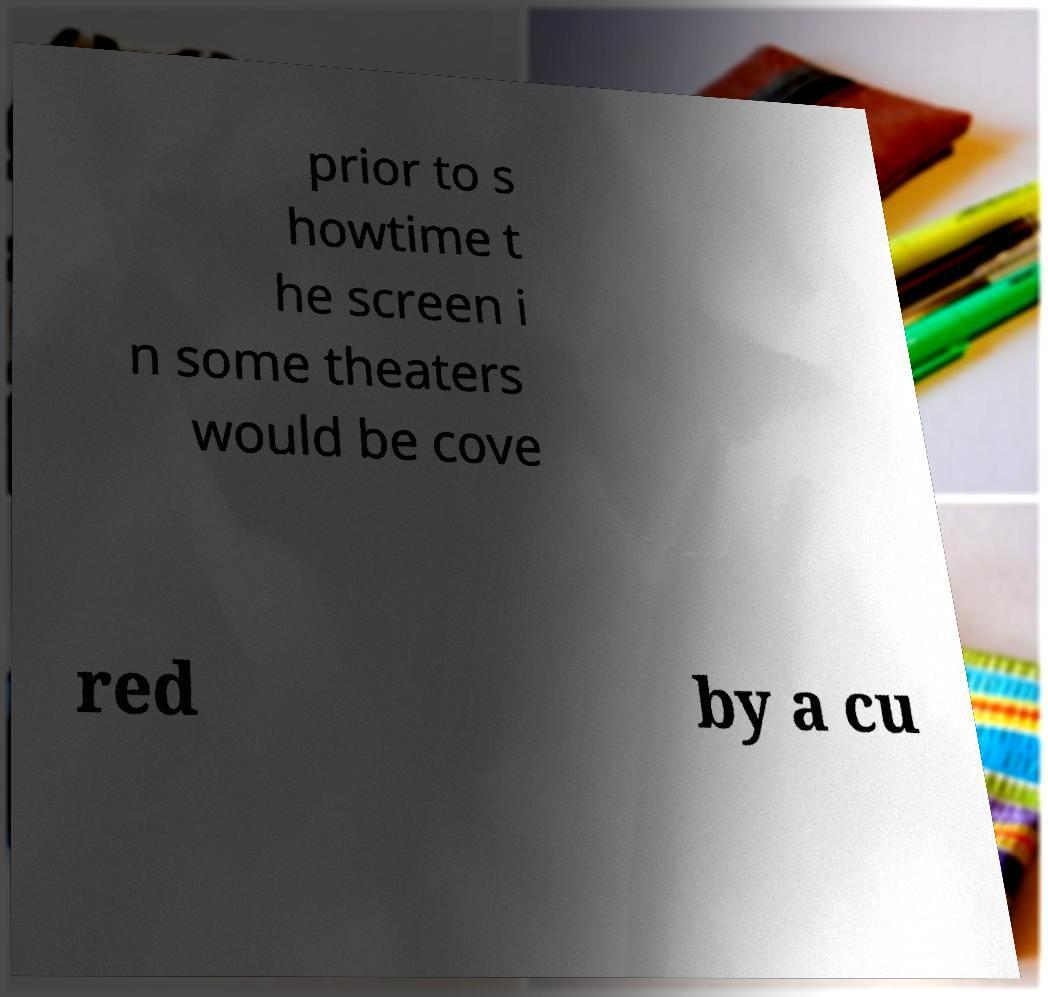I need the written content from this picture converted into text. Can you do that? prior to s howtime t he screen i n some theaters would be cove red by a cu 